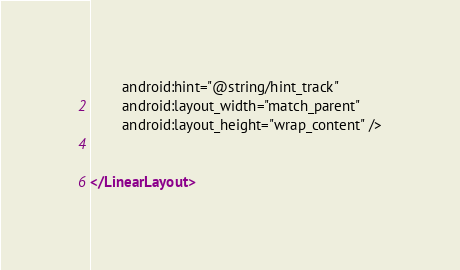Convert code to text. <code><loc_0><loc_0><loc_500><loc_500><_XML_>        android:hint="@string/hint_track"
        android:layout_width="match_parent"
        android:layout_height="wrap_content" />


</LinearLayout></code> 